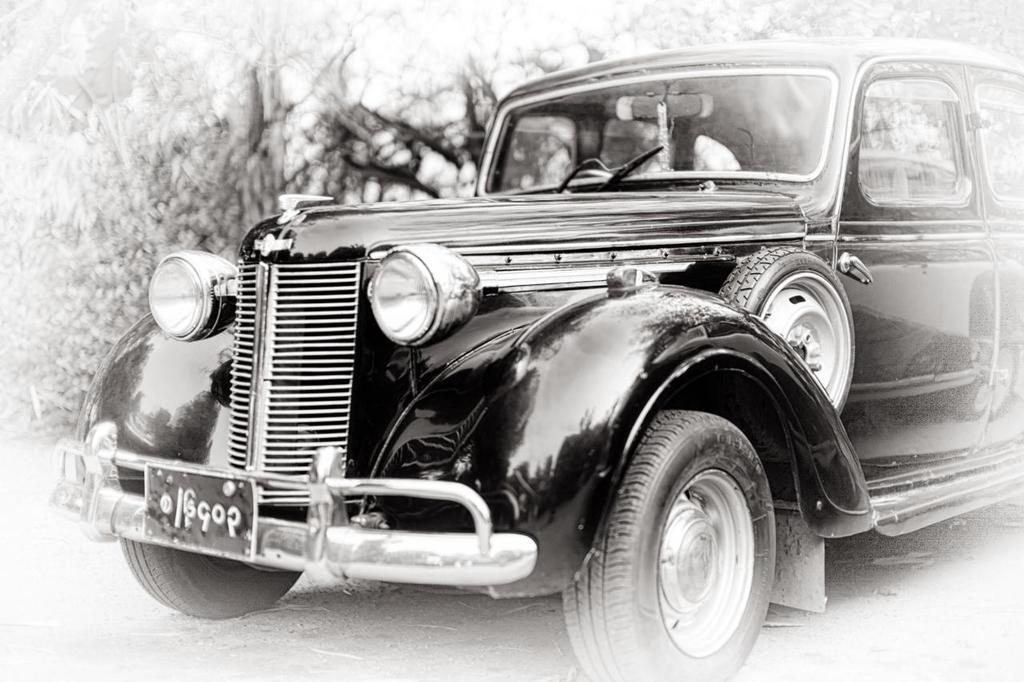What is the main subject of the image? There is a car in the image. What type of haircut does the car have in the image? The car does not have a haircut, as it is an inanimate object and cannot have a haircut. 